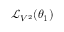Convert formula to latex. <formula><loc_0><loc_0><loc_500><loc_500>{ \mathcal { L } } _ { V ^ { 2 } } ( \theta _ { 1 } )</formula> 